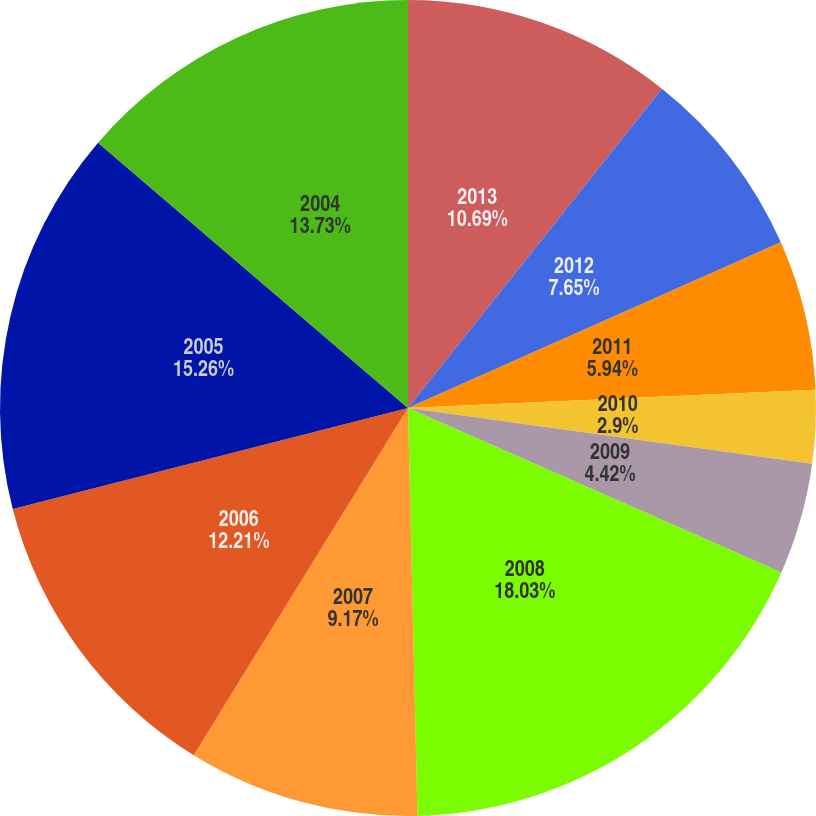<chart> <loc_0><loc_0><loc_500><loc_500><pie_chart><fcel>2013<fcel>2012<fcel>2011<fcel>2010<fcel>2009<fcel>2008<fcel>2007<fcel>2006<fcel>2005<fcel>2004<nl><fcel>10.69%<fcel>7.65%<fcel>5.94%<fcel>2.9%<fcel>4.42%<fcel>18.02%<fcel>9.17%<fcel>12.21%<fcel>15.25%<fcel>13.73%<nl></chart> 